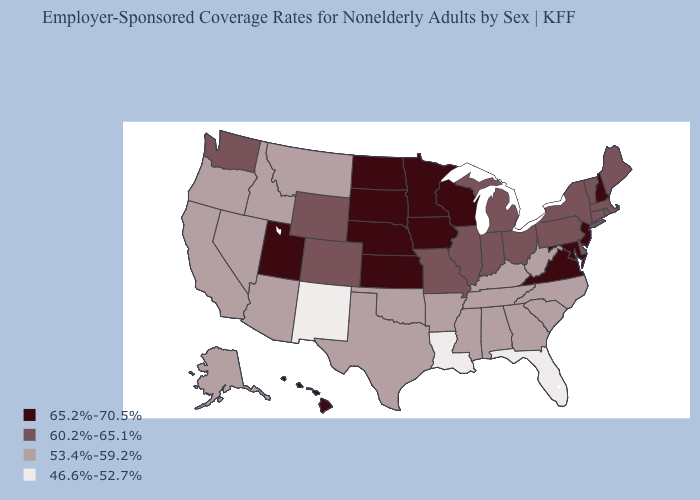Which states have the lowest value in the Northeast?
Keep it brief. Connecticut, Maine, Massachusetts, New York, Pennsylvania, Rhode Island, Vermont. What is the value of Arizona?
Quick response, please. 53.4%-59.2%. Which states have the lowest value in the MidWest?
Quick response, please. Illinois, Indiana, Michigan, Missouri, Ohio. Name the states that have a value in the range 65.2%-70.5%?
Short answer required. Hawaii, Iowa, Kansas, Maryland, Minnesota, Nebraska, New Hampshire, New Jersey, North Dakota, South Dakota, Utah, Virginia, Wisconsin. What is the highest value in the USA?
Keep it brief. 65.2%-70.5%. What is the highest value in the South ?
Short answer required. 65.2%-70.5%. What is the value of Connecticut?
Be succinct. 60.2%-65.1%. What is the lowest value in the USA?
Short answer required. 46.6%-52.7%. What is the value of New York?
Write a very short answer. 60.2%-65.1%. What is the highest value in the USA?
Be succinct. 65.2%-70.5%. What is the lowest value in states that border Missouri?
Concise answer only. 53.4%-59.2%. Is the legend a continuous bar?
Answer briefly. No. What is the lowest value in the South?
Short answer required. 46.6%-52.7%. 